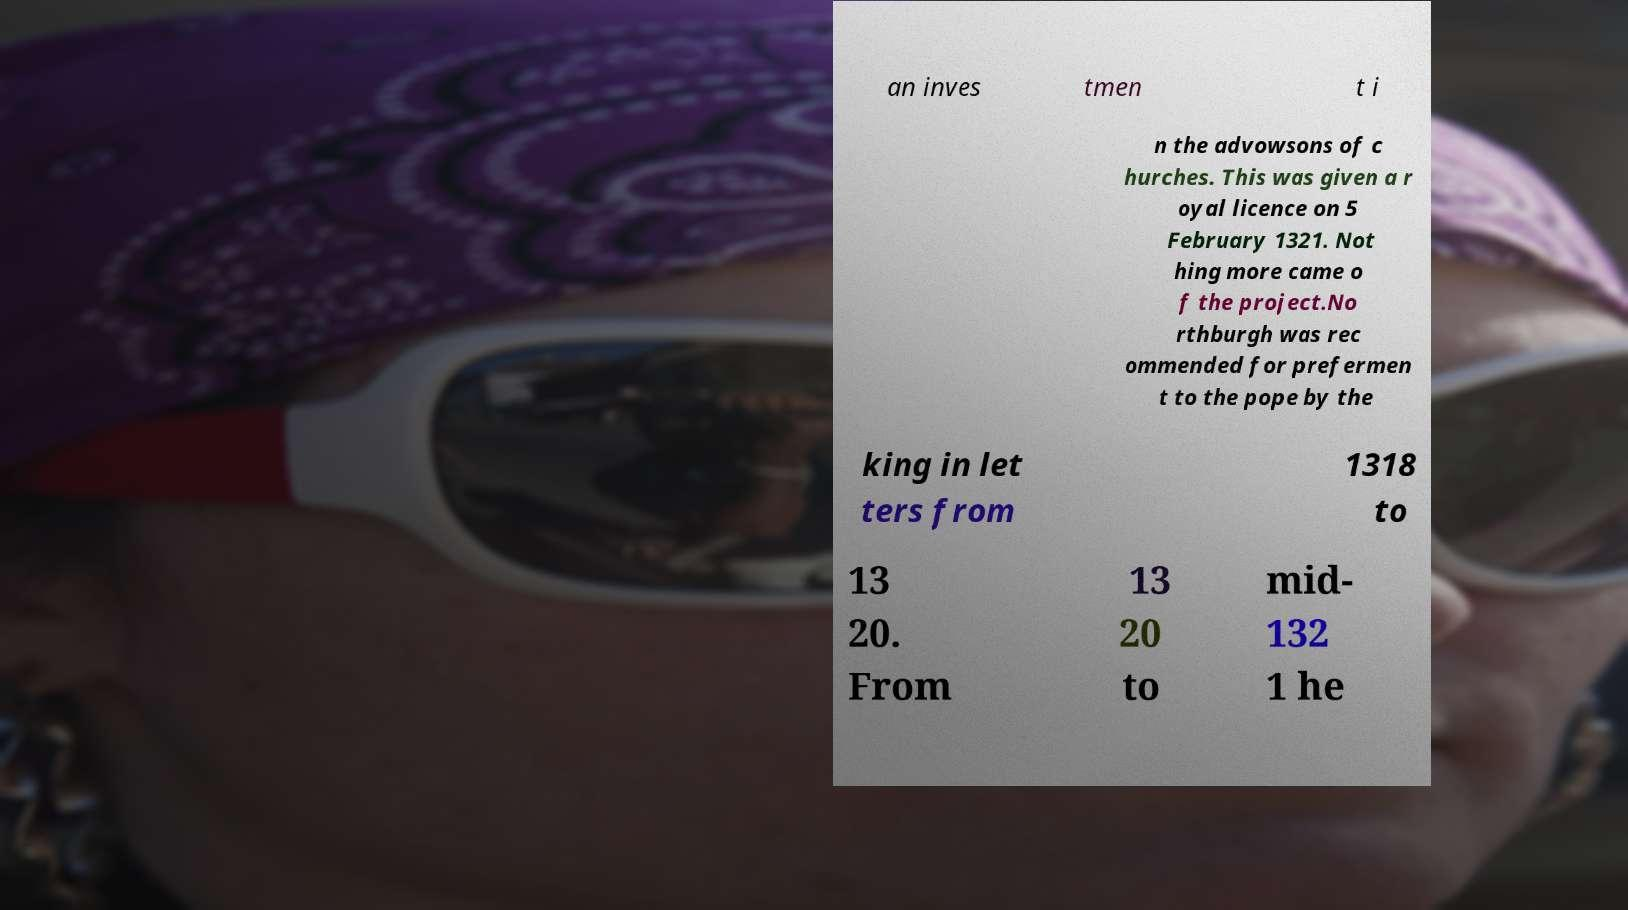Could you extract and type out the text from this image? an inves tmen t i n the advowsons of c hurches. This was given a r oyal licence on 5 February 1321. Not hing more came o f the project.No rthburgh was rec ommended for prefermen t to the pope by the king in let ters from 1318 to 13 20. From 13 20 to mid- 132 1 he 